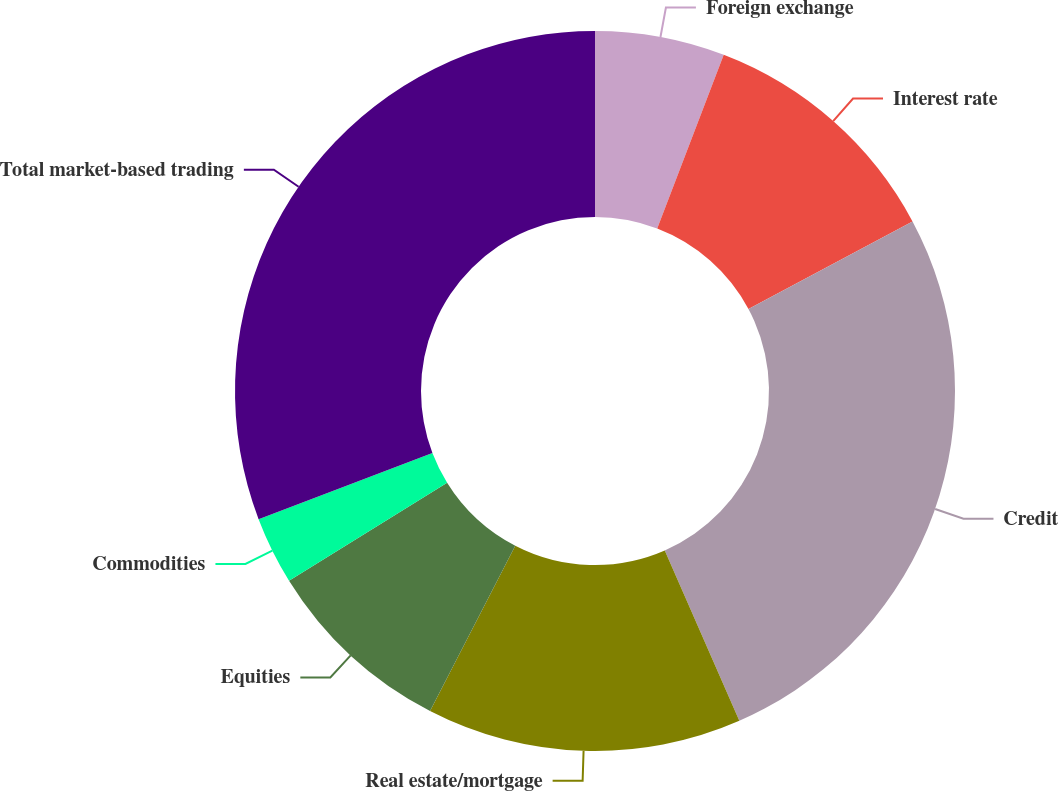Convert chart. <chart><loc_0><loc_0><loc_500><loc_500><pie_chart><fcel>Foreign exchange<fcel>Interest rate<fcel>Credit<fcel>Real estate/mortgage<fcel>Equities<fcel>Commodities<fcel>Total market-based trading<nl><fcel>5.82%<fcel>11.37%<fcel>26.24%<fcel>14.14%<fcel>8.59%<fcel>3.04%<fcel>30.79%<nl></chart> 